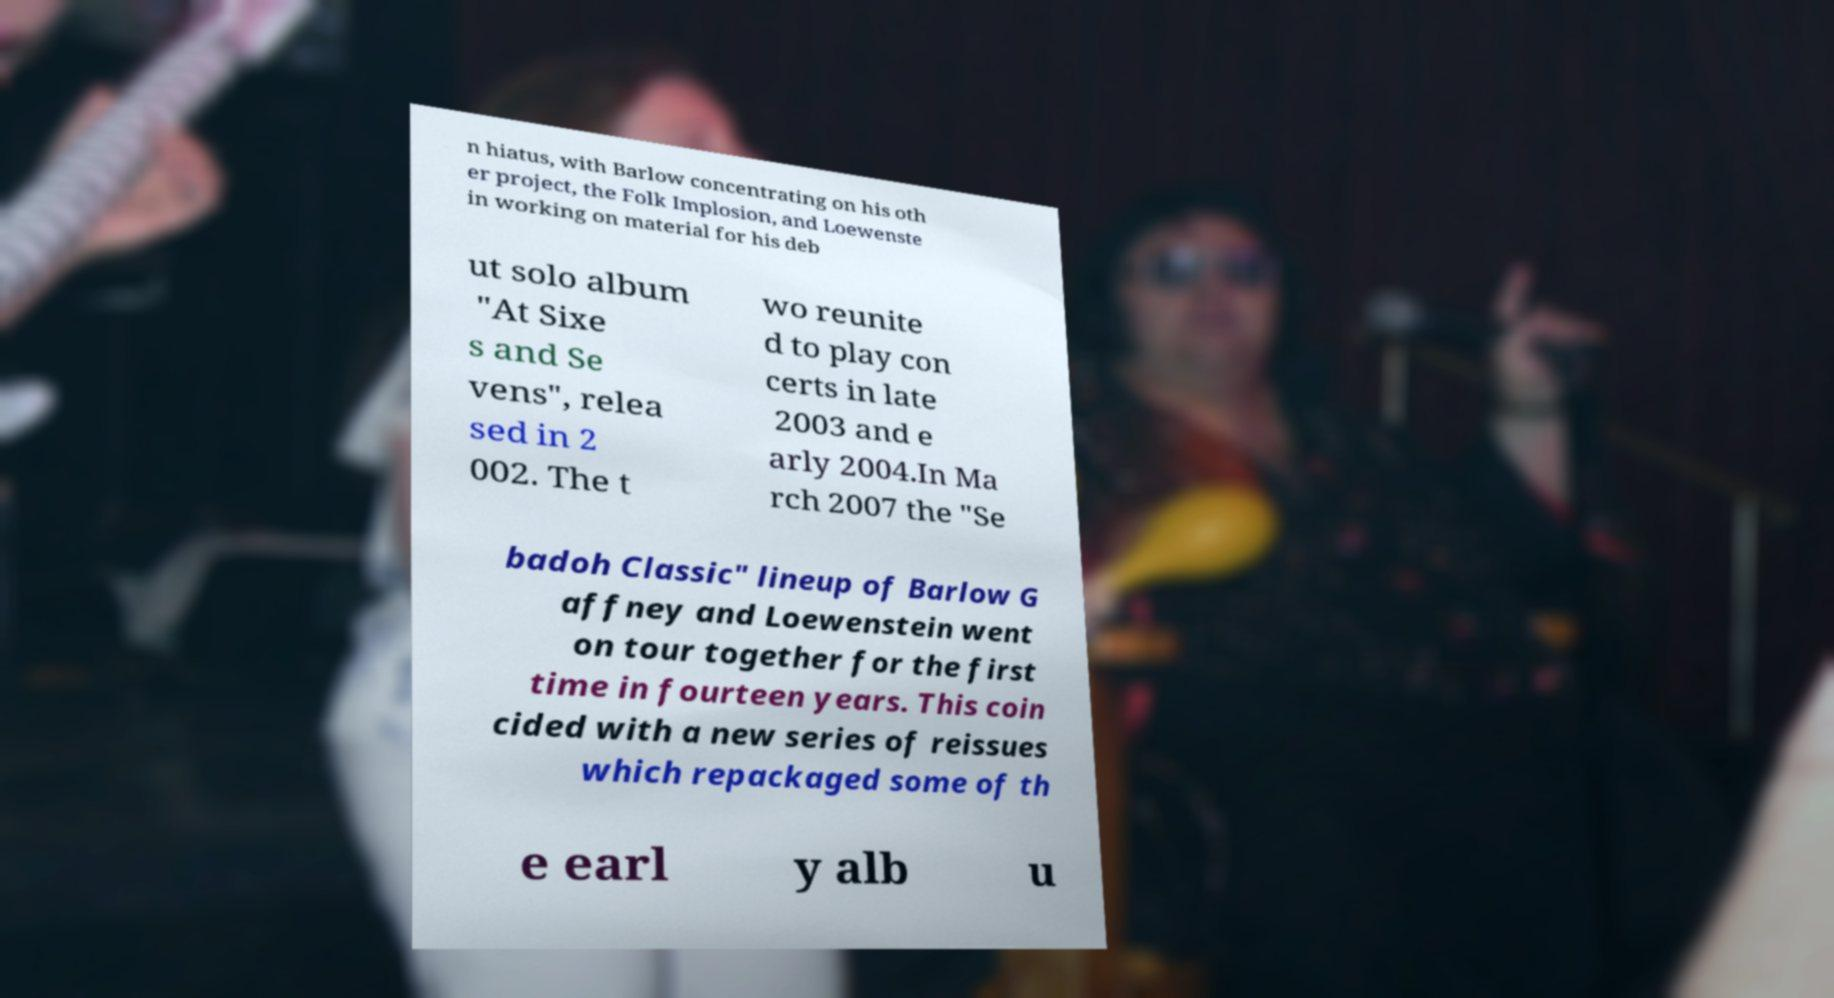Please identify and transcribe the text found in this image. n hiatus, with Barlow concentrating on his oth er project, the Folk Implosion, and Loewenste in working on material for his deb ut solo album "At Sixe s and Se vens", relea sed in 2 002. The t wo reunite d to play con certs in late 2003 and e arly 2004.In Ma rch 2007 the "Se badoh Classic" lineup of Barlow G affney and Loewenstein went on tour together for the first time in fourteen years. This coin cided with a new series of reissues which repackaged some of th e earl y alb u 